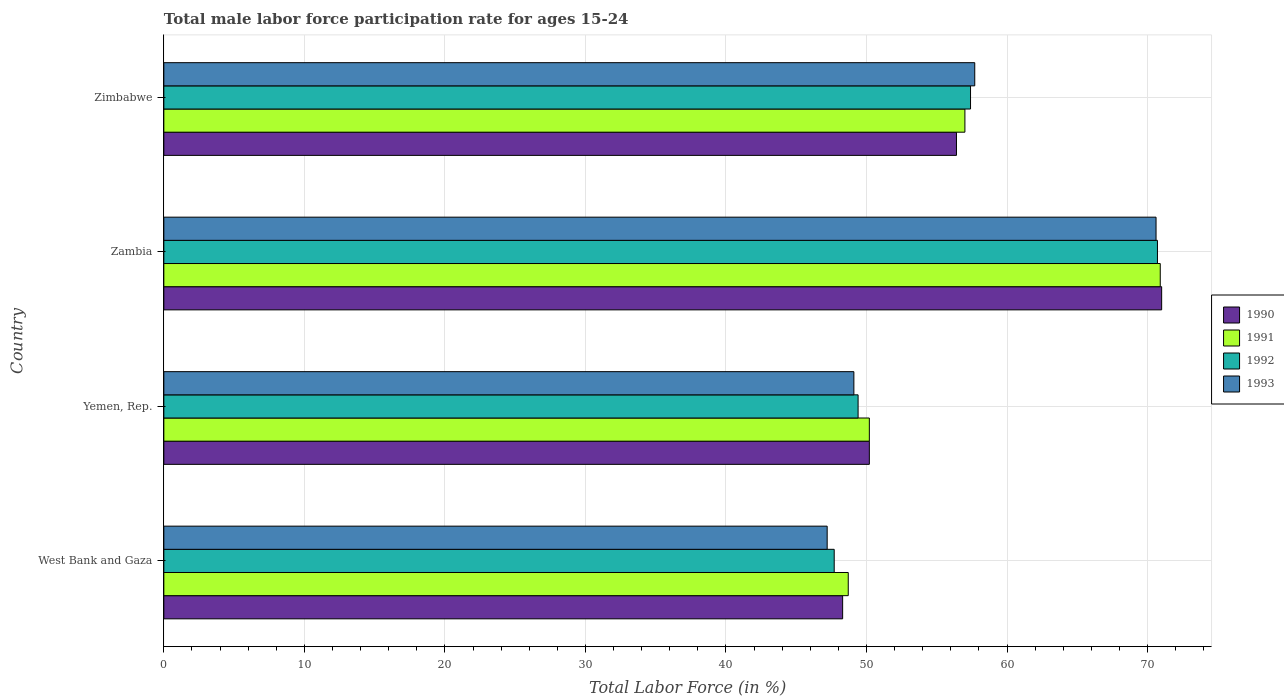How many different coloured bars are there?
Make the answer very short. 4. How many bars are there on the 2nd tick from the top?
Provide a succinct answer. 4. What is the label of the 2nd group of bars from the top?
Make the answer very short. Zambia. In how many cases, is the number of bars for a given country not equal to the number of legend labels?
Ensure brevity in your answer.  0. What is the male labor force participation rate in 1992 in Zimbabwe?
Keep it short and to the point. 57.4. Across all countries, what is the maximum male labor force participation rate in 1991?
Provide a succinct answer. 70.9. Across all countries, what is the minimum male labor force participation rate in 1993?
Provide a short and direct response. 47.2. In which country was the male labor force participation rate in 1991 maximum?
Provide a short and direct response. Zambia. In which country was the male labor force participation rate in 1990 minimum?
Give a very brief answer. West Bank and Gaza. What is the total male labor force participation rate in 1992 in the graph?
Your answer should be compact. 225.2. What is the difference between the male labor force participation rate in 1991 in West Bank and Gaza and that in Yemen, Rep.?
Provide a short and direct response. -1.5. What is the difference between the male labor force participation rate in 1991 in Zambia and the male labor force participation rate in 1992 in West Bank and Gaza?
Keep it short and to the point. 23.2. What is the average male labor force participation rate in 1993 per country?
Provide a short and direct response. 56.15. What is the ratio of the male labor force participation rate in 1993 in West Bank and Gaza to that in Yemen, Rep.?
Offer a very short reply. 0.96. Is the difference between the male labor force participation rate in 1993 in West Bank and Gaza and Yemen, Rep. greater than the difference between the male labor force participation rate in 1991 in West Bank and Gaza and Yemen, Rep.?
Your response must be concise. No. What is the difference between the highest and the second highest male labor force participation rate in 1992?
Keep it short and to the point. 13.3. What is the difference between the highest and the lowest male labor force participation rate in 1990?
Give a very brief answer. 22.7. What does the 3rd bar from the top in West Bank and Gaza represents?
Your answer should be very brief. 1991. Is it the case that in every country, the sum of the male labor force participation rate in 1993 and male labor force participation rate in 1991 is greater than the male labor force participation rate in 1992?
Give a very brief answer. Yes. How many bars are there?
Ensure brevity in your answer.  16. What is the difference between two consecutive major ticks on the X-axis?
Ensure brevity in your answer.  10. Does the graph contain any zero values?
Offer a very short reply. No. Does the graph contain grids?
Give a very brief answer. Yes. How many legend labels are there?
Give a very brief answer. 4. What is the title of the graph?
Make the answer very short. Total male labor force participation rate for ages 15-24. What is the label or title of the X-axis?
Provide a succinct answer. Total Labor Force (in %). What is the Total Labor Force (in %) in 1990 in West Bank and Gaza?
Make the answer very short. 48.3. What is the Total Labor Force (in %) in 1991 in West Bank and Gaza?
Offer a terse response. 48.7. What is the Total Labor Force (in %) in 1992 in West Bank and Gaza?
Your answer should be very brief. 47.7. What is the Total Labor Force (in %) in 1993 in West Bank and Gaza?
Ensure brevity in your answer.  47.2. What is the Total Labor Force (in %) in 1990 in Yemen, Rep.?
Offer a terse response. 50.2. What is the Total Labor Force (in %) of 1991 in Yemen, Rep.?
Offer a very short reply. 50.2. What is the Total Labor Force (in %) of 1992 in Yemen, Rep.?
Keep it short and to the point. 49.4. What is the Total Labor Force (in %) of 1993 in Yemen, Rep.?
Ensure brevity in your answer.  49.1. What is the Total Labor Force (in %) of 1991 in Zambia?
Your answer should be very brief. 70.9. What is the Total Labor Force (in %) in 1992 in Zambia?
Keep it short and to the point. 70.7. What is the Total Labor Force (in %) in 1993 in Zambia?
Ensure brevity in your answer.  70.6. What is the Total Labor Force (in %) of 1990 in Zimbabwe?
Provide a succinct answer. 56.4. What is the Total Labor Force (in %) of 1992 in Zimbabwe?
Give a very brief answer. 57.4. What is the Total Labor Force (in %) in 1993 in Zimbabwe?
Your response must be concise. 57.7. Across all countries, what is the maximum Total Labor Force (in %) in 1990?
Provide a short and direct response. 71. Across all countries, what is the maximum Total Labor Force (in %) of 1991?
Offer a terse response. 70.9. Across all countries, what is the maximum Total Labor Force (in %) of 1992?
Provide a short and direct response. 70.7. Across all countries, what is the maximum Total Labor Force (in %) in 1993?
Your answer should be compact. 70.6. Across all countries, what is the minimum Total Labor Force (in %) of 1990?
Ensure brevity in your answer.  48.3. Across all countries, what is the minimum Total Labor Force (in %) of 1991?
Provide a short and direct response. 48.7. Across all countries, what is the minimum Total Labor Force (in %) in 1992?
Make the answer very short. 47.7. Across all countries, what is the minimum Total Labor Force (in %) of 1993?
Keep it short and to the point. 47.2. What is the total Total Labor Force (in %) in 1990 in the graph?
Your response must be concise. 225.9. What is the total Total Labor Force (in %) in 1991 in the graph?
Offer a terse response. 226.8. What is the total Total Labor Force (in %) in 1992 in the graph?
Your answer should be very brief. 225.2. What is the total Total Labor Force (in %) of 1993 in the graph?
Your answer should be very brief. 224.6. What is the difference between the Total Labor Force (in %) in 1992 in West Bank and Gaza and that in Yemen, Rep.?
Your answer should be very brief. -1.7. What is the difference between the Total Labor Force (in %) in 1990 in West Bank and Gaza and that in Zambia?
Your answer should be very brief. -22.7. What is the difference between the Total Labor Force (in %) of 1991 in West Bank and Gaza and that in Zambia?
Provide a succinct answer. -22.2. What is the difference between the Total Labor Force (in %) in 1992 in West Bank and Gaza and that in Zambia?
Offer a terse response. -23. What is the difference between the Total Labor Force (in %) in 1993 in West Bank and Gaza and that in Zambia?
Make the answer very short. -23.4. What is the difference between the Total Labor Force (in %) in 1990 in West Bank and Gaza and that in Zimbabwe?
Your answer should be very brief. -8.1. What is the difference between the Total Labor Force (in %) in 1990 in Yemen, Rep. and that in Zambia?
Your answer should be very brief. -20.8. What is the difference between the Total Labor Force (in %) of 1991 in Yemen, Rep. and that in Zambia?
Your response must be concise. -20.7. What is the difference between the Total Labor Force (in %) of 1992 in Yemen, Rep. and that in Zambia?
Keep it short and to the point. -21.3. What is the difference between the Total Labor Force (in %) of 1993 in Yemen, Rep. and that in Zambia?
Ensure brevity in your answer.  -21.5. What is the difference between the Total Labor Force (in %) in 1990 in Yemen, Rep. and that in Zimbabwe?
Keep it short and to the point. -6.2. What is the difference between the Total Labor Force (in %) in 1990 in West Bank and Gaza and the Total Labor Force (in %) in 1991 in Yemen, Rep.?
Ensure brevity in your answer.  -1.9. What is the difference between the Total Labor Force (in %) of 1990 in West Bank and Gaza and the Total Labor Force (in %) of 1992 in Yemen, Rep.?
Your answer should be compact. -1.1. What is the difference between the Total Labor Force (in %) of 1990 in West Bank and Gaza and the Total Labor Force (in %) of 1993 in Yemen, Rep.?
Make the answer very short. -0.8. What is the difference between the Total Labor Force (in %) of 1990 in West Bank and Gaza and the Total Labor Force (in %) of 1991 in Zambia?
Provide a short and direct response. -22.6. What is the difference between the Total Labor Force (in %) in 1990 in West Bank and Gaza and the Total Labor Force (in %) in 1992 in Zambia?
Ensure brevity in your answer.  -22.4. What is the difference between the Total Labor Force (in %) of 1990 in West Bank and Gaza and the Total Labor Force (in %) of 1993 in Zambia?
Make the answer very short. -22.3. What is the difference between the Total Labor Force (in %) in 1991 in West Bank and Gaza and the Total Labor Force (in %) in 1993 in Zambia?
Offer a very short reply. -21.9. What is the difference between the Total Labor Force (in %) of 1992 in West Bank and Gaza and the Total Labor Force (in %) of 1993 in Zambia?
Keep it short and to the point. -22.9. What is the difference between the Total Labor Force (in %) in 1990 in West Bank and Gaza and the Total Labor Force (in %) in 1991 in Zimbabwe?
Your response must be concise. -8.7. What is the difference between the Total Labor Force (in %) of 1991 in West Bank and Gaza and the Total Labor Force (in %) of 1992 in Zimbabwe?
Your response must be concise. -8.7. What is the difference between the Total Labor Force (in %) in 1990 in Yemen, Rep. and the Total Labor Force (in %) in 1991 in Zambia?
Keep it short and to the point. -20.7. What is the difference between the Total Labor Force (in %) in 1990 in Yemen, Rep. and the Total Labor Force (in %) in 1992 in Zambia?
Make the answer very short. -20.5. What is the difference between the Total Labor Force (in %) of 1990 in Yemen, Rep. and the Total Labor Force (in %) of 1993 in Zambia?
Make the answer very short. -20.4. What is the difference between the Total Labor Force (in %) in 1991 in Yemen, Rep. and the Total Labor Force (in %) in 1992 in Zambia?
Make the answer very short. -20.5. What is the difference between the Total Labor Force (in %) in 1991 in Yemen, Rep. and the Total Labor Force (in %) in 1993 in Zambia?
Offer a very short reply. -20.4. What is the difference between the Total Labor Force (in %) of 1992 in Yemen, Rep. and the Total Labor Force (in %) of 1993 in Zambia?
Your answer should be very brief. -21.2. What is the difference between the Total Labor Force (in %) of 1991 in Yemen, Rep. and the Total Labor Force (in %) of 1992 in Zimbabwe?
Your answer should be compact. -7.2. What is the difference between the Total Labor Force (in %) of 1990 in Zambia and the Total Labor Force (in %) of 1992 in Zimbabwe?
Offer a very short reply. 13.6. What is the average Total Labor Force (in %) in 1990 per country?
Provide a short and direct response. 56.48. What is the average Total Labor Force (in %) in 1991 per country?
Offer a terse response. 56.7. What is the average Total Labor Force (in %) in 1992 per country?
Offer a terse response. 56.3. What is the average Total Labor Force (in %) of 1993 per country?
Keep it short and to the point. 56.15. What is the difference between the Total Labor Force (in %) in 1991 and Total Labor Force (in %) in 1992 in West Bank and Gaza?
Your answer should be very brief. 1. What is the difference between the Total Labor Force (in %) of 1991 and Total Labor Force (in %) of 1993 in West Bank and Gaza?
Make the answer very short. 1.5. What is the difference between the Total Labor Force (in %) of 1991 and Total Labor Force (in %) of 1993 in Yemen, Rep.?
Offer a very short reply. 1.1. What is the difference between the Total Labor Force (in %) of 1992 and Total Labor Force (in %) of 1993 in Yemen, Rep.?
Your answer should be compact. 0.3. What is the difference between the Total Labor Force (in %) of 1990 and Total Labor Force (in %) of 1992 in Zambia?
Make the answer very short. 0.3. What is the difference between the Total Labor Force (in %) of 1990 and Total Labor Force (in %) of 1993 in Zambia?
Give a very brief answer. 0.4. What is the difference between the Total Labor Force (in %) of 1991 and Total Labor Force (in %) of 1992 in Zambia?
Your response must be concise. 0.2. What is the difference between the Total Labor Force (in %) in 1991 and Total Labor Force (in %) in 1993 in Zambia?
Your answer should be very brief. 0.3. What is the difference between the Total Labor Force (in %) in 1990 and Total Labor Force (in %) in 1992 in Zimbabwe?
Ensure brevity in your answer.  -1. What is the difference between the Total Labor Force (in %) of 1991 and Total Labor Force (in %) of 1993 in Zimbabwe?
Offer a terse response. -0.7. What is the difference between the Total Labor Force (in %) of 1992 and Total Labor Force (in %) of 1993 in Zimbabwe?
Your answer should be compact. -0.3. What is the ratio of the Total Labor Force (in %) of 1990 in West Bank and Gaza to that in Yemen, Rep.?
Your answer should be compact. 0.96. What is the ratio of the Total Labor Force (in %) in 1991 in West Bank and Gaza to that in Yemen, Rep.?
Give a very brief answer. 0.97. What is the ratio of the Total Labor Force (in %) of 1992 in West Bank and Gaza to that in Yemen, Rep.?
Offer a very short reply. 0.97. What is the ratio of the Total Labor Force (in %) in 1993 in West Bank and Gaza to that in Yemen, Rep.?
Offer a very short reply. 0.96. What is the ratio of the Total Labor Force (in %) of 1990 in West Bank and Gaza to that in Zambia?
Provide a short and direct response. 0.68. What is the ratio of the Total Labor Force (in %) in 1991 in West Bank and Gaza to that in Zambia?
Make the answer very short. 0.69. What is the ratio of the Total Labor Force (in %) of 1992 in West Bank and Gaza to that in Zambia?
Give a very brief answer. 0.67. What is the ratio of the Total Labor Force (in %) of 1993 in West Bank and Gaza to that in Zambia?
Make the answer very short. 0.67. What is the ratio of the Total Labor Force (in %) of 1990 in West Bank and Gaza to that in Zimbabwe?
Your response must be concise. 0.86. What is the ratio of the Total Labor Force (in %) of 1991 in West Bank and Gaza to that in Zimbabwe?
Your answer should be very brief. 0.85. What is the ratio of the Total Labor Force (in %) in 1992 in West Bank and Gaza to that in Zimbabwe?
Keep it short and to the point. 0.83. What is the ratio of the Total Labor Force (in %) in 1993 in West Bank and Gaza to that in Zimbabwe?
Provide a short and direct response. 0.82. What is the ratio of the Total Labor Force (in %) in 1990 in Yemen, Rep. to that in Zambia?
Your answer should be compact. 0.71. What is the ratio of the Total Labor Force (in %) in 1991 in Yemen, Rep. to that in Zambia?
Provide a short and direct response. 0.71. What is the ratio of the Total Labor Force (in %) of 1992 in Yemen, Rep. to that in Zambia?
Your response must be concise. 0.7. What is the ratio of the Total Labor Force (in %) in 1993 in Yemen, Rep. to that in Zambia?
Your answer should be very brief. 0.7. What is the ratio of the Total Labor Force (in %) of 1990 in Yemen, Rep. to that in Zimbabwe?
Offer a very short reply. 0.89. What is the ratio of the Total Labor Force (in %) of 1991 in Yemen, Rep. to that in Zimbabwe?
Ensure brevity in your answer.  0.88. What is the ratio of the Total Labor Force (in %) in 1992 in Yemen, Rep. to that in Zimbabwe?
Make the answer very short. 0.86. What is the ratio of the Total Labor Force (in %) in 1993 in Yemen, Rep. to that in Zimbabwe?
Give a very brief answer. 0.85. What is the ratio of the Total Labor Force (in %) of 1990 in Zambia to that in Zimbabwe?
Provide a short and direct response. 1.26. What is the ratio of the Total Labor Force (in %) of 1991 in Zambia to that in Zimbabwe?
Offer a terse response. 1.24. What is the ratio of the Total Labor Force (in %) of 1992 in Zambia to that in Zimbabwe?
Provide a succinct answer. 1.23. What is the ratio of the Total Labor Force (in %) in 1993 in Zambia to that in Zimbabwe?
Your answer should be very brief. 1.22. What is the difference between the highest and the second highest Total Labor Force (in %) of 1991?
Ensure brevity in your answer.  13.9. What is the difference between the highest and the second highest Total Labor Force (in %) of 1992?
Make the answer very short. 13.3. What is the difference between the highest and the second highest Total Labor Force (in %) in 1993?
Offer a terse response. 12.9. What is the difference between the highest and the lowest Total Labor Force (in %) of 1990?
Offer a very short reply. 22.7. What is the difference between the highest and the lowest Total Labor Force (in %) in 1993?
Give a very brief answer. 23.4. 